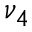<formula> <loc_0><loc_0><loc_500><loc_500>\nu _ { 4 }</formula> 